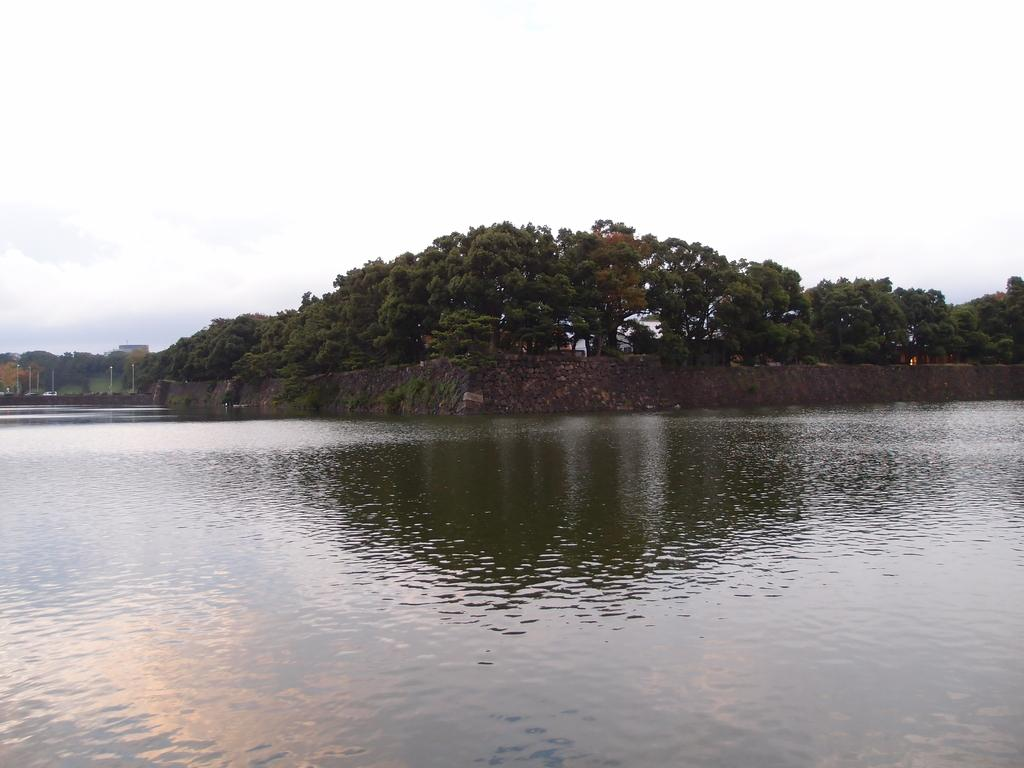What is the primary element visible in the image? There is water in the image. What other objects can be seen near the water? There is a rock near the water in the image. What structures are present in the image? There are poles in the image. What type of natural environment is depicted in the image? There are many trees in the image, indicating a forest or wooded area. What is visible in the background of the image? The sky is visible in the background of the image. What type of lamp is hanging from the tree in the image? There is no lamp present in the image; it features water, a rock, poles, trees, and the sky. What kind of meal is being prepared near the water in the image? There is no meal preparation visible in the image; it only shows water, a rock, poles, trees, and the sky. 